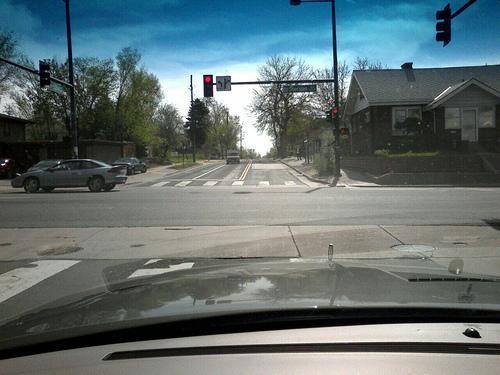How many cars are shown crossing the street?
Give a very brief answer. 1. How many cars are in the photo?
Give a very brief answer. 2. 